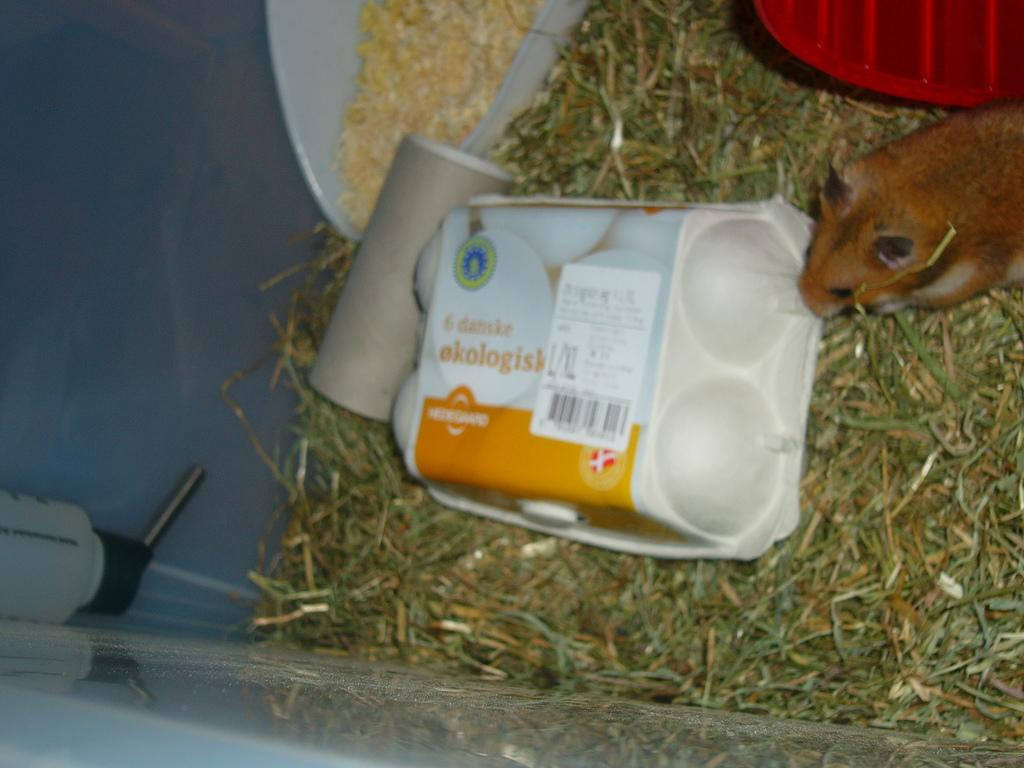What type of surface is visible in the image? There is a floor in the image. What type of vegetation is present in the image? There is grass in the image. What object is used for holding eggs in the image? There is an egg tray in the image. What small animal can be seen in the image? There is a mouse in the image. What is the color of the basket at the top of the image? There is a red color basket at the top of the image. What type of quilt is being used to cover the feast in the image? There is no feast or quilt present in the image. How many fingers can be seen interacting with the egg tray in the image? There is no reference to fingers or their interaction with the egg tray in the image. 